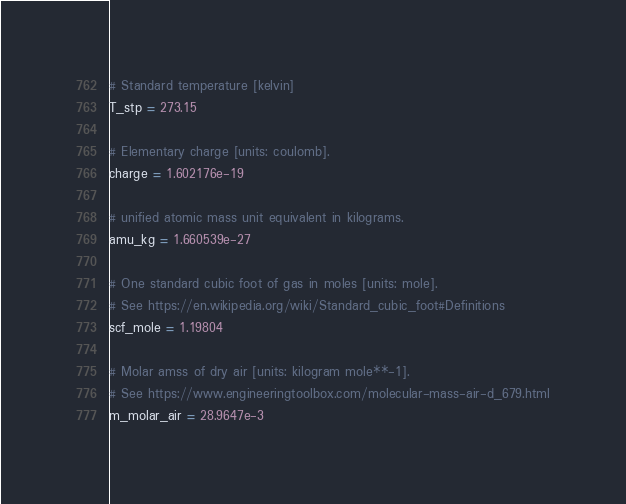Convert code to text. <code><loc_0><loc_0><loc_500><loc_500><_Python_>
# Standard temperature [kelvin]
T_stp = 273.15

# Elementary charge [units: coulomb].
charge = 1.602176e-19

# unified atomic mass unit equivalent in kilograms.
amu_kg = 1.660539e-27

# One standard cubic foot of gas in moles [units: mole].
# See https://en.wikipedia.org/wiki/Standard_cubic_foot#Definitions
scf_mole = 1.19804

# Molar amss of dry air [units: kilogram mole**-1].
# See https://www.engineeringtoolbox.com/molecular-mass-air-d_679.html
m_molar_air = 28.9647e-3
</code> 